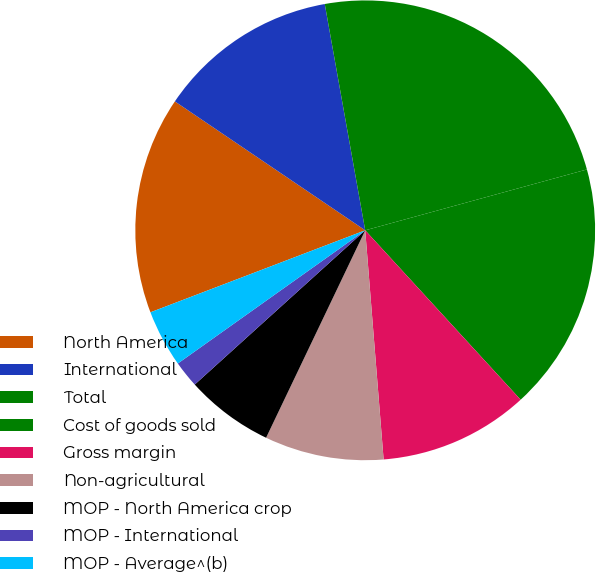Convert chart to OTSL. <chart><loc_0><loc_0><loc_500><loc_500><pie_chart><fcel>North America<fcel>International<fcel>Total<fcel>Cost of goods sold<fcel>Gross margin<fcel>Non-agricultural<fcel>MOP - North America crop<fcel>MOP - International<fcel>MOP - Average^(b)<nl><fcel>15.28%<fcel>12.71%<fcel>23.55%<fcel>17.45%<fcel>10.54%<fcel>8.37%<fcel>6.2%<fcel>1.87%<fcel>4.03%<nl></chart> 